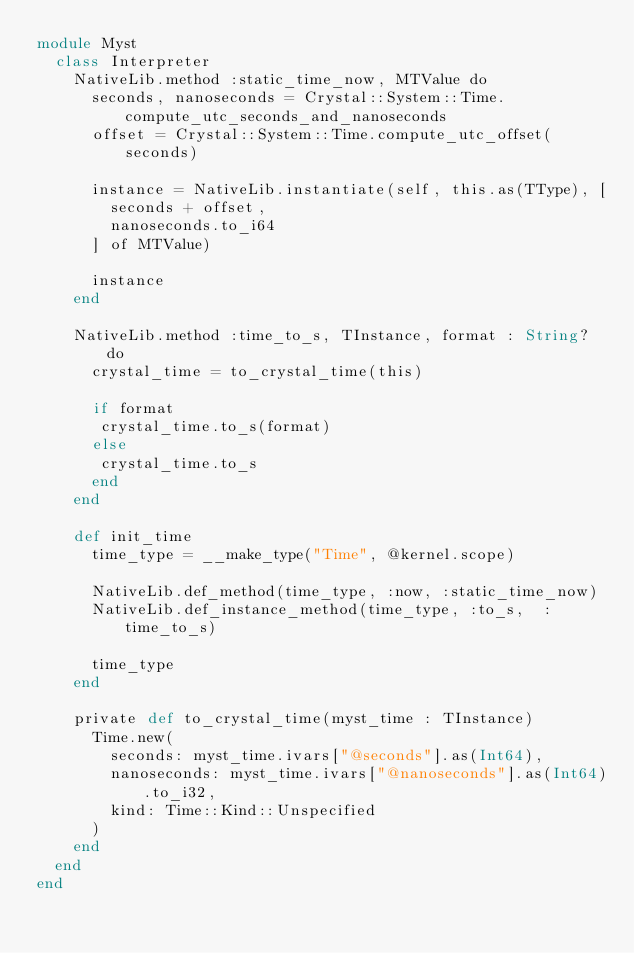Convert code to text. <code><loc_0><loc_0><loc_500><loc_500><_Crystal_>module Myst
  class Interpreter
    NativeLib.method :static_time_now, MTValue do
      seconds, nanoseconds = Crystal::System::Time.compute_utc_seconds_and_nanoseconds
      offset = Crystal::System::Time.compute_utc_offset(seconds)

      instance = NativeLib.instantiate(self, this.as(TType), [
        seconds + offset,
        nanoseconds.to_i64
      ] of MTValue)

      instance
    end

    NativeLib.method :time_to_s, TInstance, format : String? do
      crystal_time = to_crystal_time(this)

      if format
       crystal_time.to_s(format)
      else
       crystal_time.to_s
      end
    end

    def init_time
      time_type = __make_type("Time", @kernel.scope)

      NativeLib.def_method(time_type, :now, :static_time_now)
      NativeLib.def_instance_method(time_type, :to_s,  :time_to_s)

      time_type
    end

    private def to_crystal_time(myst_time : TInstance)
      Time.new(
        seconds: myst_time.ivars["@seconds"].as(Int64),
        nanoseconds: myst_time.ivars["@nanoseconds"].as(Int64).to_i32,
        kind: Time::Kind::Unspecified
      )
    end
  end
end
</code> 